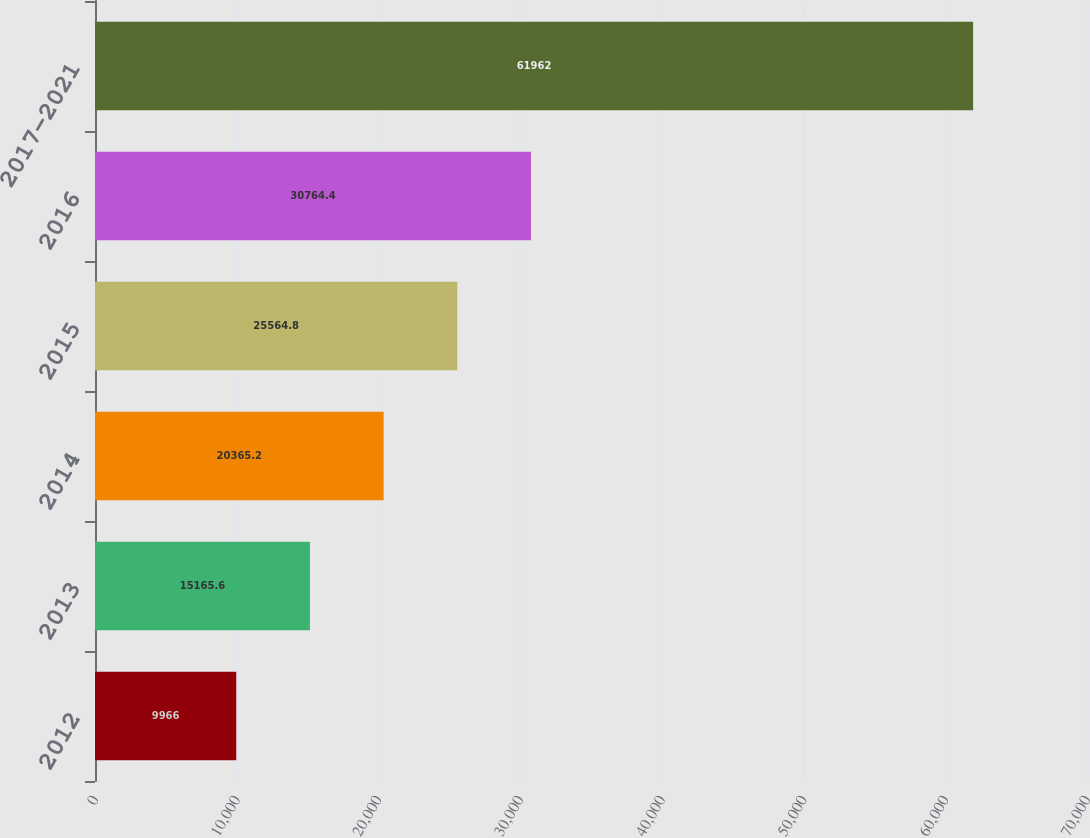<chart> <loc_0><loc_0><loc_500><loc_500><bar_chart><fcel>2012<fcel>2013<fcel>2014<fcel>2015<fcel>2016<fcel>2017-2021<nl><fcel>9966<fcel>15165.6<fcel>20365.2<fcel>25564.8<fcel>30764.4<fcel>61962<nl></chart> 